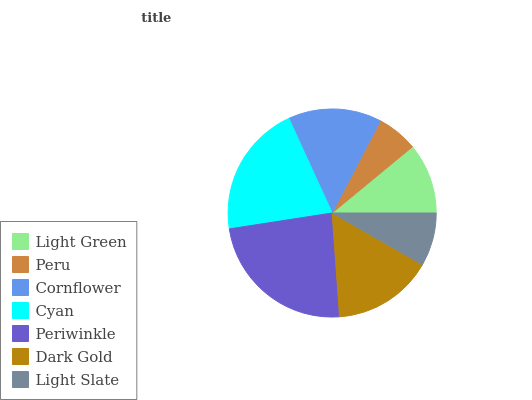Is Peru the minimum?
Answer yes or no. Yes. Is Periwinkle the maximum?
Answer yes or no. Yes. Is Cornflower the minimum?
Answer yes or no. No. Is Cornflower the maximum?
Answer yes or no. No. Is Cornflower greater than Peru?
Answer yes or no. Yes. Is Peru less than Cornflower?
Answer yes or no. Yes. Is Peru greater than Cornflower?
Answer yes or no. No. Is Cornflower less than Peru?
Answer yes or no. No. Is Cornflower the high median?
Answer yes or no. Yes. Is Cornflower the low median?
Answer yes or no. Yes. Is Periwinkle the high median?
Answer yes or no. No. Is Light Slate the low median?
Answer yes or no. No. 